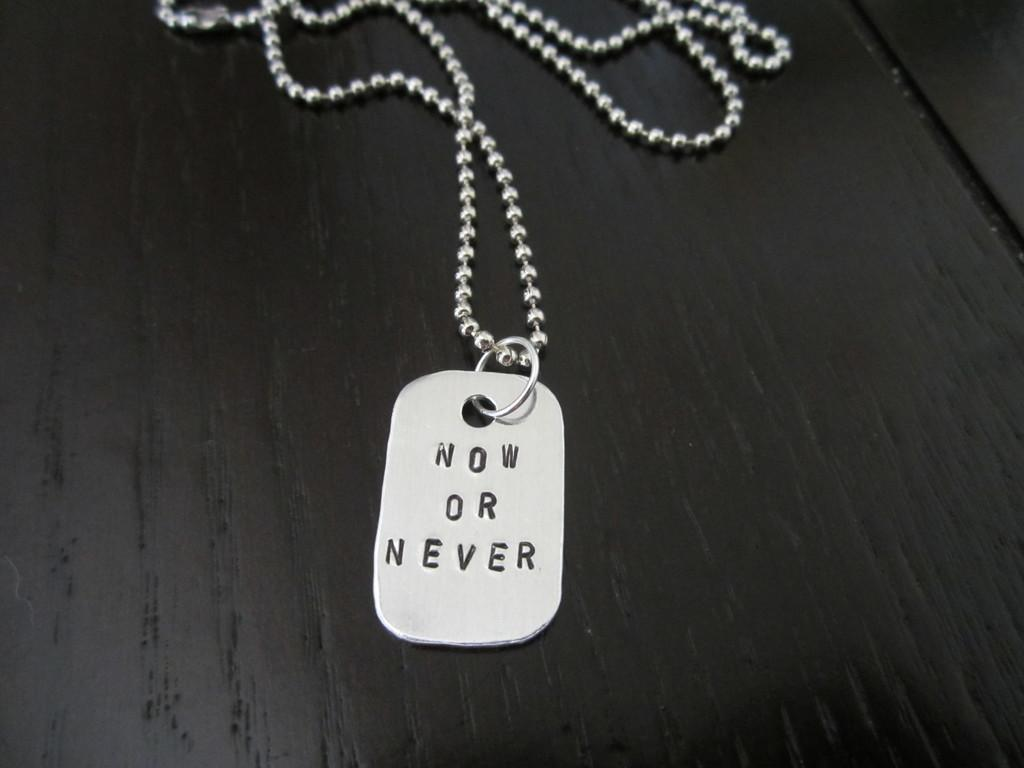What piece of furniture is present in the image? There is a table in the image. What object is placed on the table? There is a chain on the table. What is written or depicted on the chain? There is text on the chain. What type of religious symbol can be seen on top of the table in the image? There is no religious symbol present on top of the table in the image; it only features a chain with text. How many rabbits are visible on the table in the image? There are no rabbits present on the table in the image. 